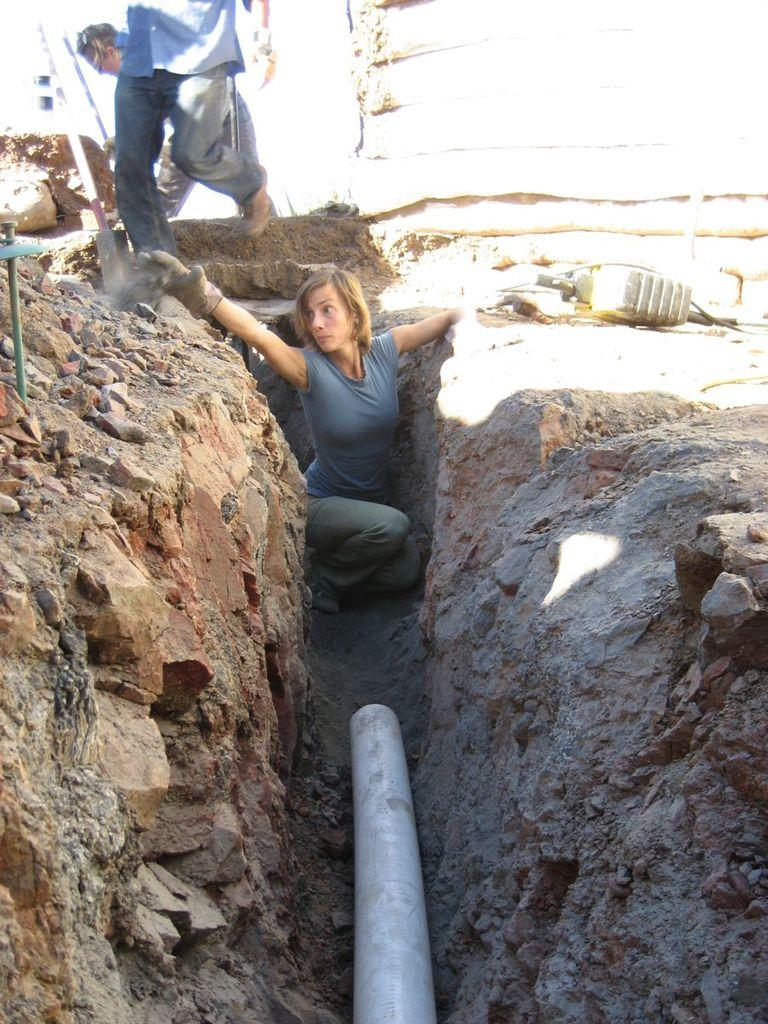How many people are in the image? There are people in the image, but the exact number is not specified. What is one person wearing in the image? One person is wearing gloves in the image. What structures can be seen in the image? There are poles and a pipe in the image. What type of object is present in the image? There is an object in the image, but its specific nature is not described. What type of natural feature is visible in the image? There are rocks in the image. What type of disease is affecting the people in the image? There is no indication of any disease affecting the people in the image. What is the weight of the object in the image? The weight of the object in the image is not mentioned in the facts provided. 